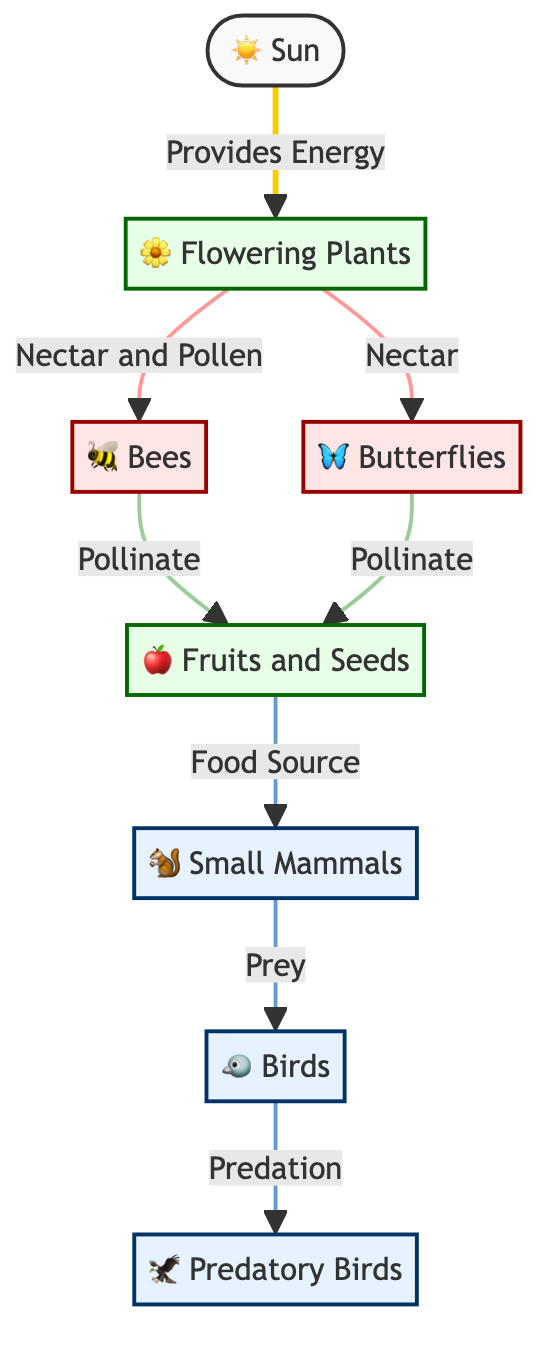What is the primary energy source in this food chain? The diagram shows the Sun as the initial node providing energy to the food chain. It is connected directly to the Flowering Plants, indicating that the Sun is the primary energy source.
Answer: Sun How many types of pollinators are represented in the diagram? The diagram lists two distinct types of pollinators: Bees and Butterflies. By counting the relevant nodes connected to Flowering Plants, we find two specific pollinator icons.
Answer: 2 What do bees primarily collect from flowering plants? The relationship between the Bees and the Flowering Plants indicates that Bees collect Nectar and Pollen. The specific edge labels provide clear evidence of what they gather.
Answer: Nectar and Pollen What do small mammals consume in this chain? The diagram indicates that Small Mammals consume Fruits and Seeds. By tracing the connections from the Fruits and Seeds node to the Small Mammals node, it is evident what they feed on.
Answer: Fruits and Seeds Which type of birds is considered a predator in this food chain? Predatory Birds are explicitly noted as the node that follows Birds in the hierarchy of consumers. Analyzing the tier structure reveals the role of these birds as predators.
Answer: Predatory Birds How many consumer nodes are present in the diagram? By counting the consumer nodes (Small Mammals, Birds, Predatory Birds) connected in the flow of the diagram, we find there are three distinct consumer nodes aligned below the producers and pollinators.
Answer: 3 How do butterflies contribute to the food chain? The diagram shows that Butterflies contribute by Pollinating the Fruits and Seeds. Understanding their role involves examining their direct connection to the Fruits and Seeds node, which they pollinate.
Answer: Pollinate What is the role of flowering plants in this food chain? Flowering Plants serve as producers in the food chain, providing Nectar and Pollen for pollinators and Fruits and Seeds for consumers. This is deduced from the connections they have with Bees, Butterflies, and the Fruits and Seeds.
Answer: Producers 